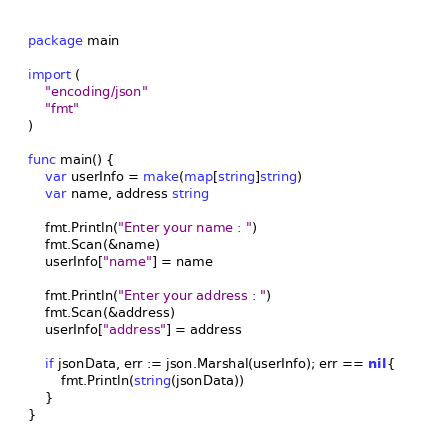Convert code to text. <code><loc_0><loc_0><loc_500><loc_500><_Go_>package main

import (
	"encoding/json"
	"fmt"
)

func main() {
	var userInfo = make(map[string]string)
	var name, address string

	fmt.Println("Enter your name : ")
	fmt.Scan(&name)
	userInfo["name"] = name

	fmt.Println("Enter your address : ")
	fmt.Scan(&address)
	userInfo["address"] = address

	if jsonData, err := json.Marshal(userInfo); err == nil {
		fmt.Println(string(jsonData))
	}
}
</code> 